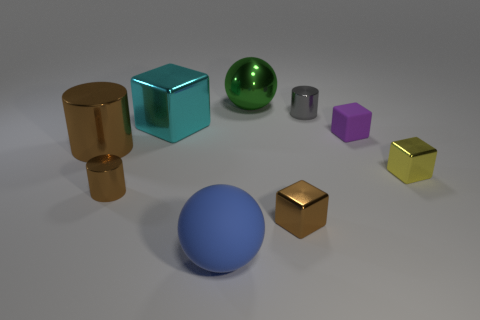Subtract all small cylinders. How many cylinders are left? 1 Subtract all yellow blocks. Subtract all green cylinders. How many blocks are left? 3 Subtract all red blocks. How many purple cylinders are left? 0 Subtract all small blue metal balls. Subtract all large things. How many objects are left? 5 Add 9 brown blocks. How many brown blocks are left? 10 Add 1 purple cubes. How many purple cubes exist? 2 Subtract all blue balls. How many balls are left? 1 Subtract 0 green cubes. How many objects are left? 9 Subtract all cylinders. How many objects are left? 6 Subtract 1 cylinders. How many cylinders are left? 2 